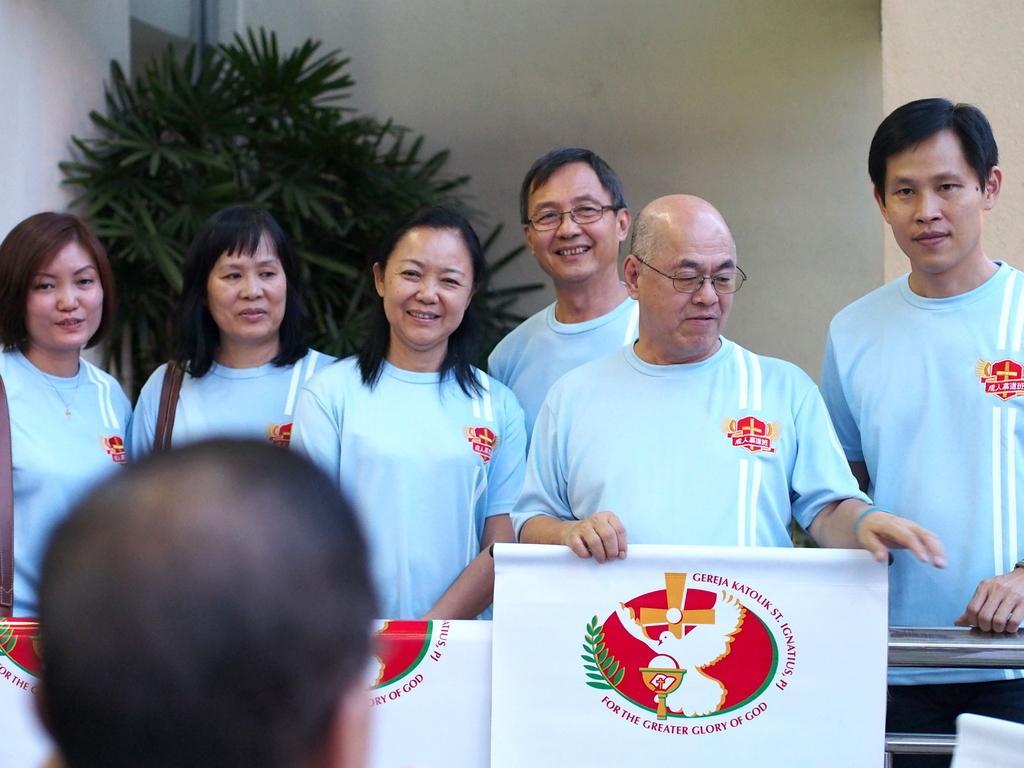Could you give a brief overview of what you see in this image? In this image we can see three women and three men wearing the same the t shirt and standing and smiling. We can also see a man holding the banner and the banner consists of the logo and text. In the background we can see the plant and also the wall. On the left there is some person. 